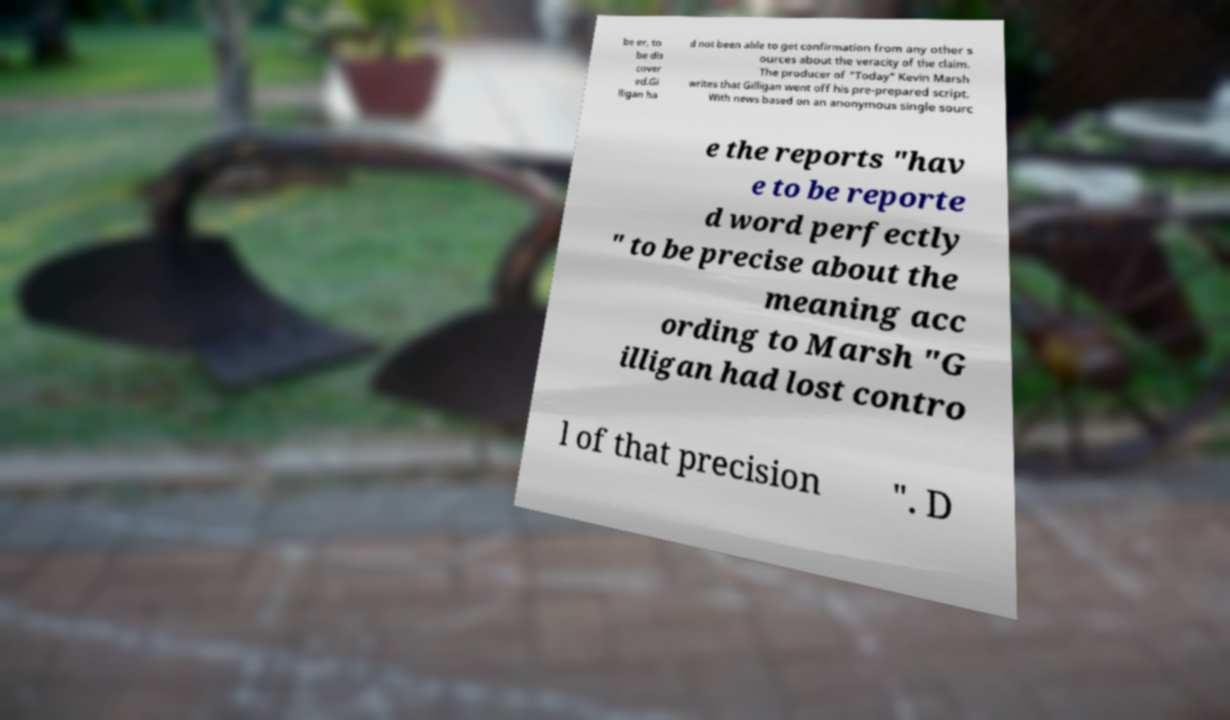Can you accurately transcribe the text from the provided image for me? be er, to be dis cover ed.Gi lligan ha d not been able to get confirmation from any other s ources about the veracity of the claim. The producer of "Today" Kevin Marsh writes that Gilligan went off his pre-prepared script. With news based on an anonymous single sourc e the reports "hav e to be reporte d word perfectly " to be precise about the meaning acc ording to Marsh "G illigan had lost contro l of that precision ". D 